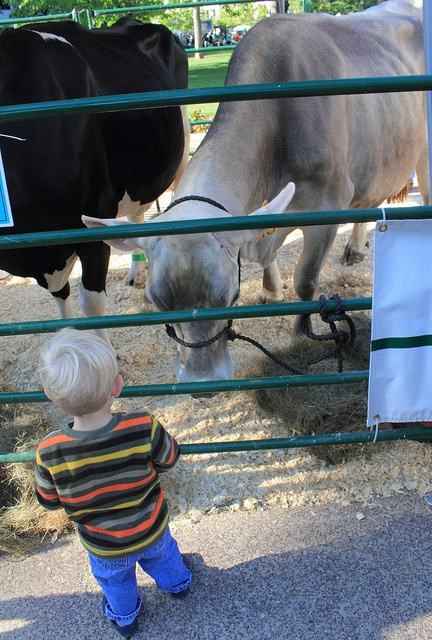Describe the objects in this image and their specific colors. I can see horse in black, darkgray, gray, and teal tones, cow in black, darkgray, and gray tones, cow in black, gray, and darkgray tones, people in black, darkgray, gray, and blue tones, and people in black, blue, darkgray, lightgray, and darkblue tones in this image. 